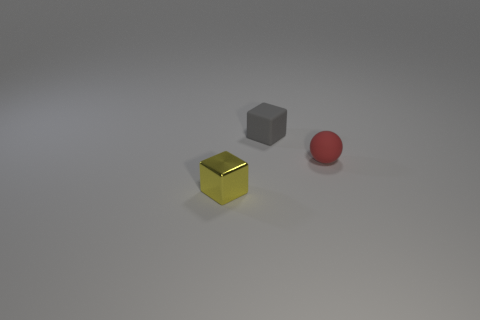What is the color of the other tiny rubber thing that is the same shape as the yellow object?
Offer a very short reply. Gray. What number of tiny matte cubes are the same color as the matte sphere?
Your answer should be compact. 0. There is a small cube that is in front of the matte thing that is in front of the tiny block on the right side of the tiny metal object; what color is it?
Your answer should be very brief. Yellow. Is the material of the red ball the same as the small gray block?
Your answer should be compact. Yes. Is the shape of the small yellow metallic object the same as the small gray thing?
Keep it short and to the point. Yes. Is the number of tiny gray matte objects behind the small yellow thing the same as the number of spheres that are right of the tiny red rubber object?
Your answer should be very brief. No. There is a small object that is the same material as the small red ball; what is its color?
Give a very brief answer. Gray. How many things have the same material as the ball?
Offer a very short reply. 1. There is a matte object behind the red thing; does it have the same color as the matte ball?
Provide a short and direct response. No. What number of red matte objects are the same shape as the tiny yellow object?
Give a very brief answer. 0. 